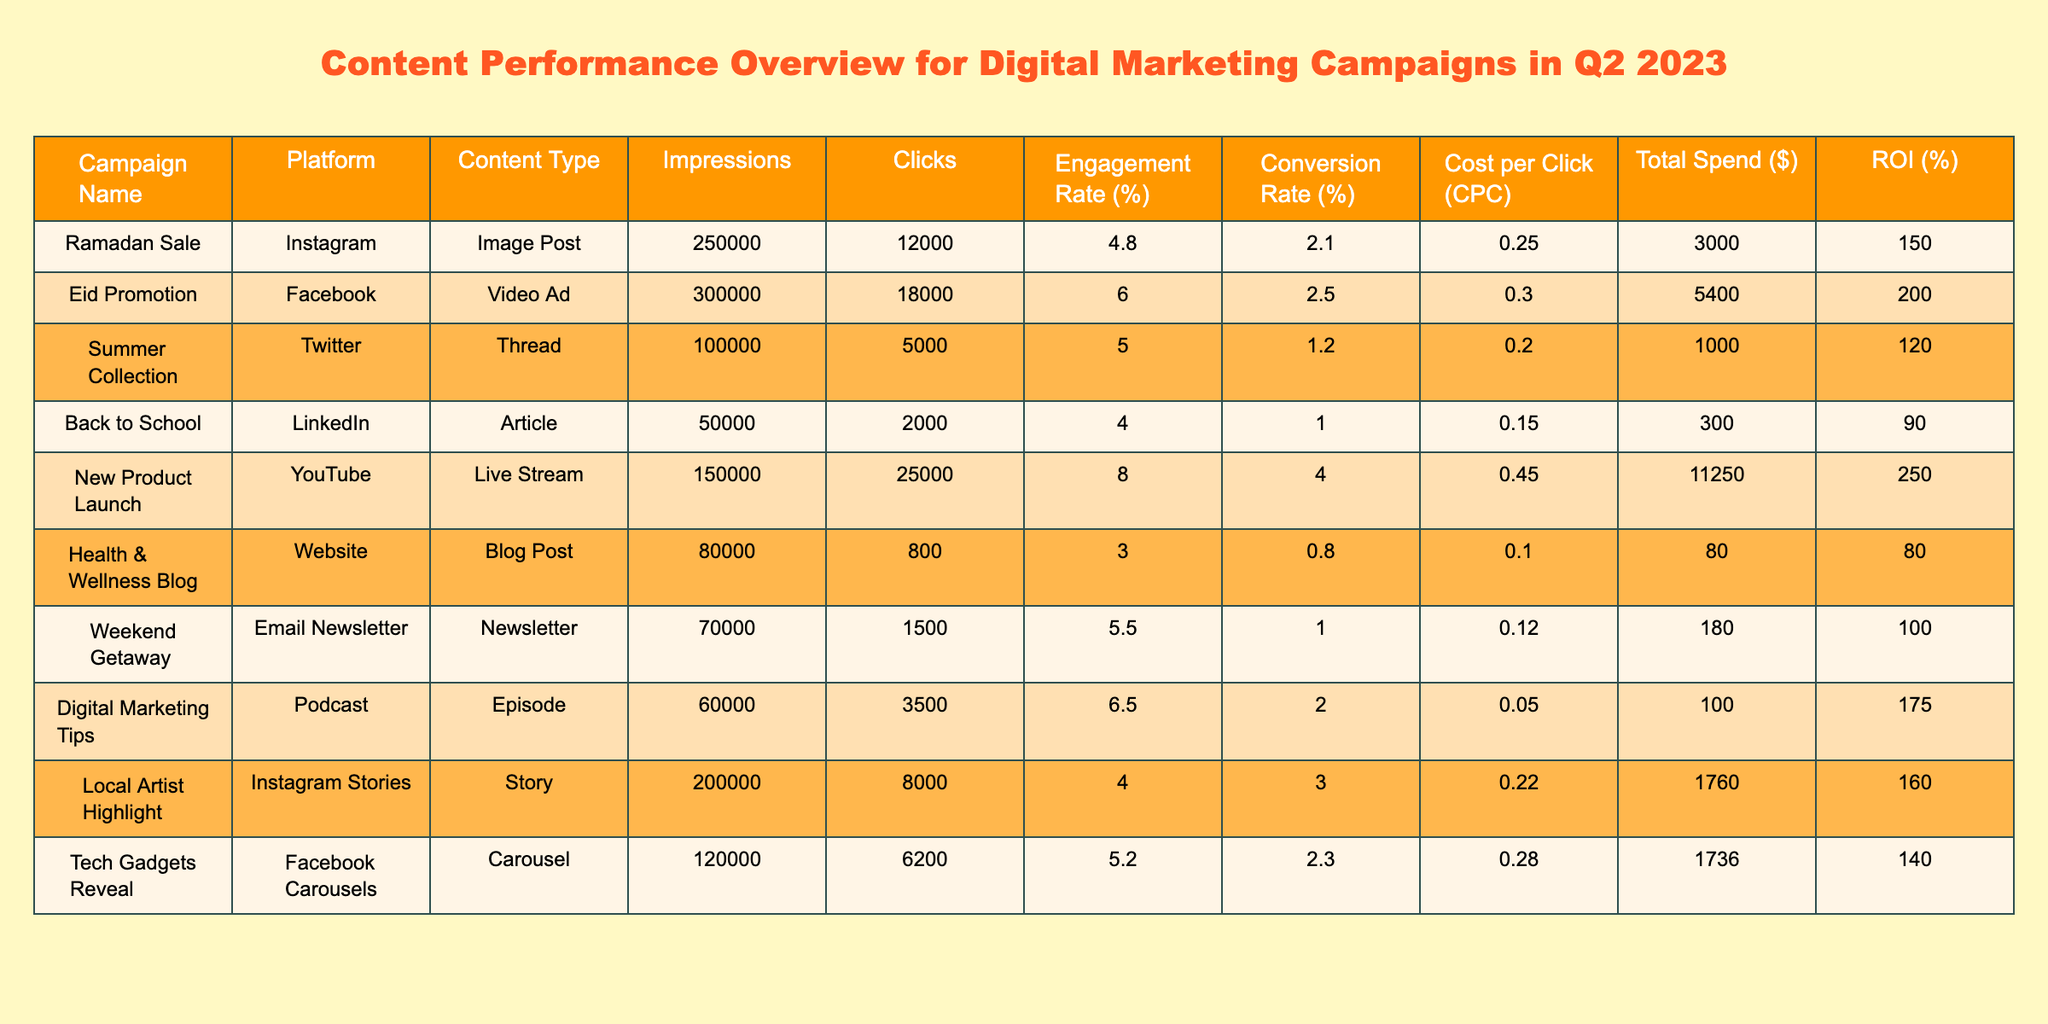What is the total spend for the Eid Promotion campaign? The table shows a Total Spend of $5400 for the Eid Promotion campaign.
Answer: $5400 Which content type had the highest engagement rate? By comparing the Engagement Rate (%) column, the New Product Launch has the highest rate at 8.0%.
Answer: 8.0% How many clicks did the Ramadan Sale campaign receive? The Ramadan Sale campaign received 12,000 clicks, as shown in the Clicks column.
Answer: 12000 What is the Conversion Rate for the Summer Collection campaign? The Summer Collection campaign has a Conversion Rate of 1.2%, as indicated in the table.
Answer: 1.2% Which campaign had the lowest ROI? The Back to School campaign has the lowest ROI at 90%, which is the smallest value in the ROI (%) column.
Answer: 90 What is the average CPC for all campaigns listed in the table? The Cost per Click (CPC) values are: 0.25, 0.30, 0.20, 0.15, 0.45, 0.10, 0.12, 0.05, 0.22, 0.28. The sum of these values is 1.77 and there are 10 campaigns, so the average is 1.77 / 10 = 0.177.
Answer: 0.177 Did any campaign exceed 250,000 impressions? Yes, both the Ramadan Sale and Eid Promotion campaigns exceeded 250,000 impressions, with 250,000 and 300,000 impressions respectively.
Answer: Yes Which platform had the highest total spend across all campaigns? The total spends for each platform are: Instagram (3000) + Facebook (5400) + Twitter (1000) + LinkedIn (300) + YouTube (11250) + Website (80) + Email (180) + Podcast (100) = $15410 for Facebook, which is the highest spend.
Answer: Facebook If we consider the total clicks across all campaigns, how many clicks were received altogether? Adding the Clicks for all campaigns: 12000 (Ramadan Sale) + 18000 (Eid Promotion) + 5000 (Summer Collection) + 2000 (Back to School) + 25000 (New Product Launch) + 800 (Health & Wellness Blog) + 1500 (Weekend Getaway) + 3500 (Digital Marketing Tips) + 8000 (Local Artist Highlight) + 6200 (Tech Gadgets Reveal) gives a total of 74000 clicks across all campaigns.
Answer: 74000 Which campaign had the highest conversion rate? The New Product Launch campaign has the highest conversion rate at 4.0%, according to the Conversion Rate (%) column.
Answer: 4.0% 